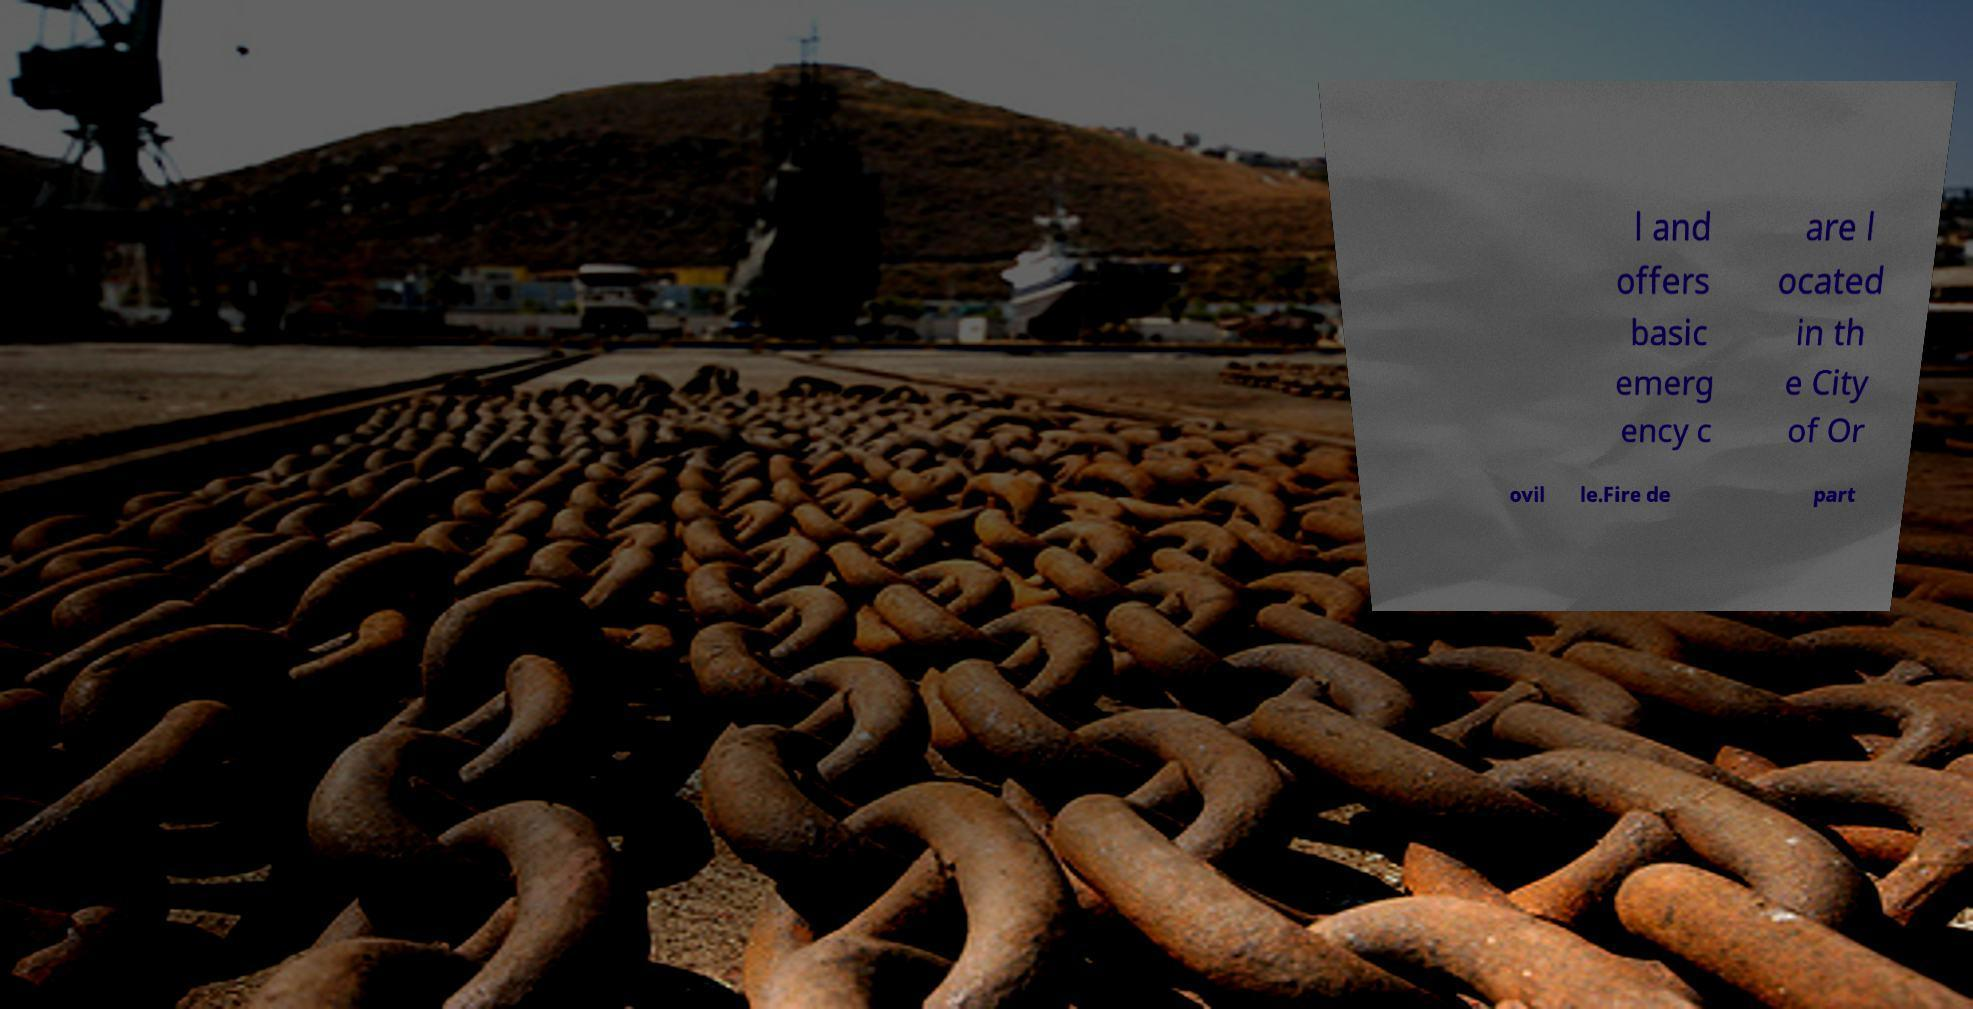Can you read and provide the text displayed in the image?This photo seems to have some interesting text. Can you extract and type it out for me? l and offers basic emerg ency c are l ocated in th e City of Or ovil le.Fire de part 